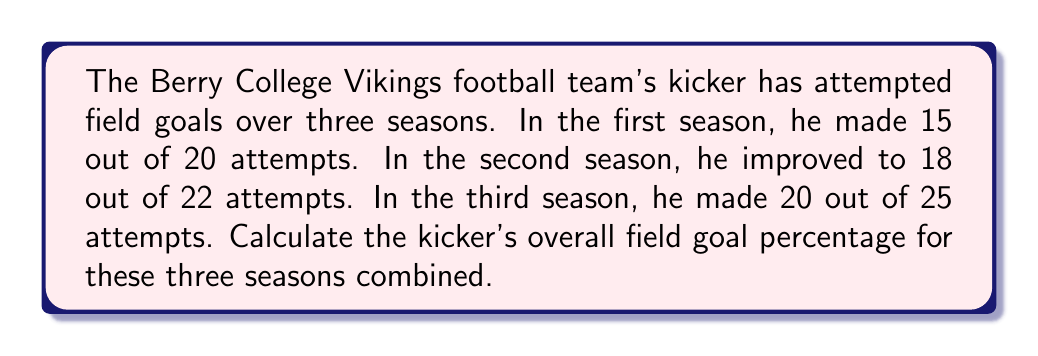Could you help me with this problem? To calculate the overall field goal percentage, we need to follow these steps:

1. Calculate the total number of successful field goals:
   $15 + 18 + 20 = 53$ successful field goals

2. Calculate the total number of field goal attempts:
   $20 + 22 + 25 = 67$ total attempts

3. Calculate the field goal percentage using the formula:
   $$ \text{Field Goal Percentage} = \frac{\text{Successful Field Goals}}{\text{Total Attempts}} \times 100\% $$

4. Plug in the values:
   $$ \text{Field Goal Percentage} = \frac{53}{67} \times 100\% $$

5. Perform the division:
   $$ \text{Field Goal Percentage} = 0.7910447761... \times 100\% $$

6. Round to two decimal places:
   $$ \text{Field Goal Percentage} = 79.10\% $$
Answer: 79.10% 